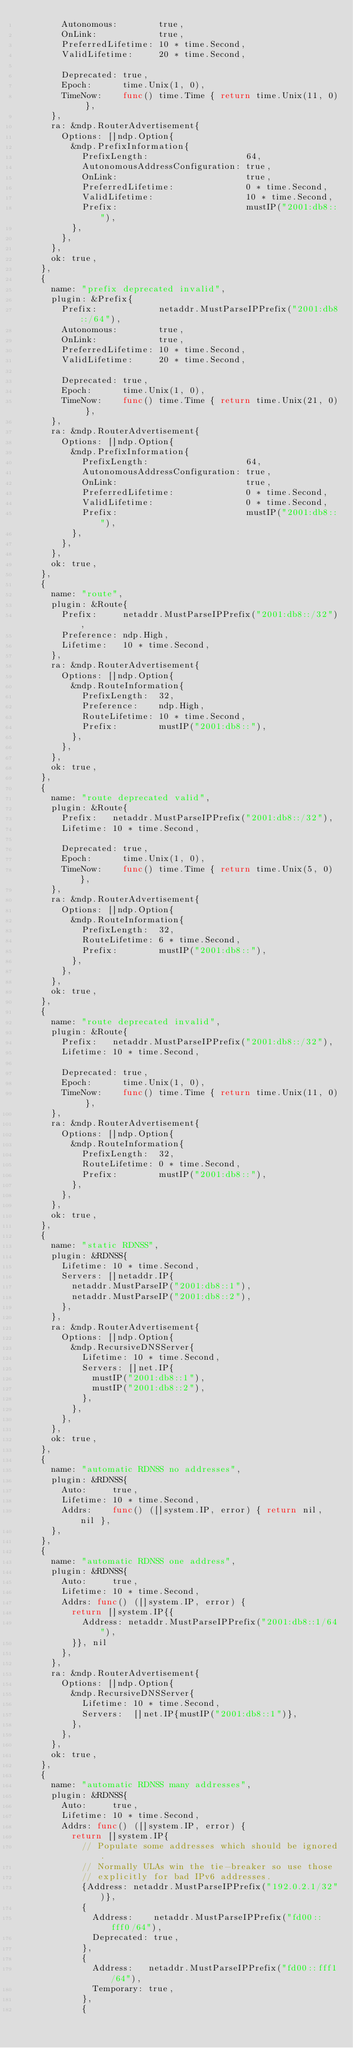<code> <loc_0><loc_0><loc_500><loc_500><_Go_>				Autonomous:        true,
				OnLink:            true,
				PreferredLifetime: 10 * time.Second,
				ValidLifetime:     20 * time.Second,

				Deprecated: true,
				Epoch:      time.Unix(1, 0),
				TimeNow:    func() time.Time { return time.Unix(11, 0) },
			},
			ra: &ndp.RouterAdvertisement{
				Options: []ndp.Option{
					&ndp.PrefixInformation{
						PrefixLength:                   64,
						AutonomousAddressConfiguration: true,
						OnLink:                         true,
						PreferredLifetime:              0 * time.Second,
						ValidLifetime:                  10 * time.Second,
						Prefix:                         mustIP("2001:db8::"),
					},
				},
			},
			ok: true,
		},
		{
			name: "prefix deprecated invalid",
			plugin: &Prefix{
				Prefix:            netaddr.MustParseIPPrefix("2001:db8::/64"),
				Autonomous:        true,
				OnLink:            true,
				PreferredLifetime: 10 * time.Second,
				ValidLifetime:     20 * time.Second,

				Deprecated: true,
				Epoch:      time.Unix(1, 0),
				TimeNow:    func() time.Time { return time.Unix(21, 0) },
			},
			ra: &ndp.RouterAdvertisement{
				Options: []ndp.Option{
					&ndp.PrefixInformation{
						PrefixLength:                   64,
						AutonomousAddressConfiguration: true,
						OnLink:                         true,
						PreferredLifetime:              0 * time.Second,
						ValidLifetime:                  0 * time.Second,
						Prefix:                         mustIP("2001:db8::"),
					},
				},
			},
			ok: true,
		},
		{
			name: "route",
			plugin: &Route{
				Prefix:     netaddr.MustParseIPPrefix("2001:db8::/32"),
				Preference: ndp.High,
				Lifetime:   10 * time.Second,
			},
			ra: &ndp.RouterAdvertisement{
				Options: []ndp.Option{
					&ndp.RouteInformation{
						PrefixLength:  32,
						Preference:    ndp.High,
						RouteLifetime: 10 * time.Second,
						Prefix:        mustIP("2001:db8::"),
					},
				},
			},
			ok: true,
		},
		{
			name: "route deprecated valid",
			plugin: &Route{
				Prefix:   netaddr.MustParseIPPrefix("2001:db8::/32"),
				Lifetime: 10 * time.Second,

				Deprecated: true,
				Epoch:      time.Unix(1, 0),
				TimeNow:    func() time.Time { return time.Unix(5, 0) },
			},
			ra: &ndp.RouterAdvertisement{
				Options: []ndp.Option{
					&ndp.RouteInformation{
						PrefixLength:  32,
						RouteLifetime: 6 * time.Second,
						Prefix:        mustIP("2001:db8::"),
					},
				},
			},
			ok: true,
		},
		{
			name: "route deprecated invalid",
			plugin: &Route{
				Prefix:   netaddr.MustParseIPPrefix("2001:db8::/32"),
				Lifetime: 10 * time.Second,

				Deprecated: true,
				Epoch:      time.Unix(1, 0),
				TimeNow:    func() time.Time { return time.Unix(11, 0) },
			},
			ra: &ndp.RouterAdvertisement{
				Options: []ndp.Option{
					&ndp.RouteInformation{
						PrefixLength:  32,
						RouteLifetime: 0 * time.Second,
						Prefix:        mustIP("2001:db8::"),
					},
				},
			},
			ok: true,
		},
		{
			name: "static RDNSS",
			plugin: &RDNSS{
				Lifetime: 10 * time.Second,
				Servers: []netaddr.IP{
					netaddr.MustParseIP("2001:db8::1"),
					netaddr.MustParseIP("2001:db8::2"),
				},
			},
			ra: &ndp.RouterAdvertisement{
				Options: []ndp.Option{
					&ndp.RecursiveDNSServer{
						Lifetime: 10 * time.Second,
						Servers: []net.IP{
							mustIP("2001:db8::1"),
							mustIP("2001:db8::2"),
						},
					},
				},
			},
			ok: true,
		},
		{
			name: "automatic RDNSS no addresses",
			plugin: &RDNSS{
				Auto:     true,
				Lifetime: 10 * time.Second,
				Addrs:    func() ([]system.IP, error) { return nil, nil },
			},
		},
		{
			name: "automatic RDNSS one address",
			plugin: &RDNSS{
				Auto:     true,
				Lifetime: 10 * time.Second,
				Addrs: func() ([]system.IP, error) {
					return []system.IP{{
						Address: netaddr.MustParseIPPrefix("2001:db8::1/64"),
					}}, nil
				},
			},
			ra: &ndp.RouterAdvertisement{
				Options: []ndp.Option{
					&ndp.RecursiveDNSServer{
						Lifetime: 10 * time.Second,
						Servers:  []net.IP{mustIP("2001:db8::1")},
					},
				},
			},
			ok: true,
		},
		{
			name: "automatic RDNSS many addresses",
			plugin: &RDNSS{
				Auto:     true,
				Lifetime: 10 * time.Second,
				Addrs: func() ([]system.IP, error) {
					return []system.IP{
						// Populate some addresses which should be ignored.
						// Normally ULAs win the tie-breaker so use those
						// explicitly for bad IPv6 addresses.
						{Address: netaddr.MustParseIPPrefix("192.0.2.1/32")},
						{
							Address:    netaddr.MustParseIPPrefix("fd00::fff0/64"),
							Deprecated: true,
						},
						{
							Address:   netaddr.MustParseIPPrefix("fd00::fff1/64"),
							Temporary: true,
						},
						{</code> 